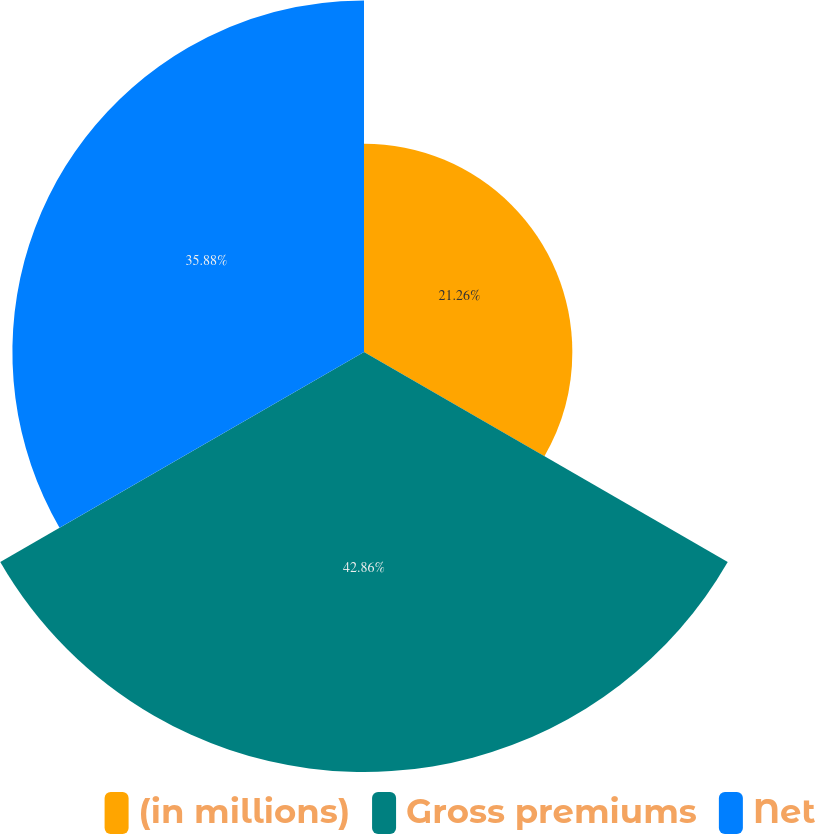<chart> <loc_0><loc_0><loc_500><loc_500><pie_chart><fcel>(in millions)<fcel>Gross premiums<fcel>Net<nl><fcel>21.26%<fcel>42.86%<fcel>35.88%<nl></chart> 